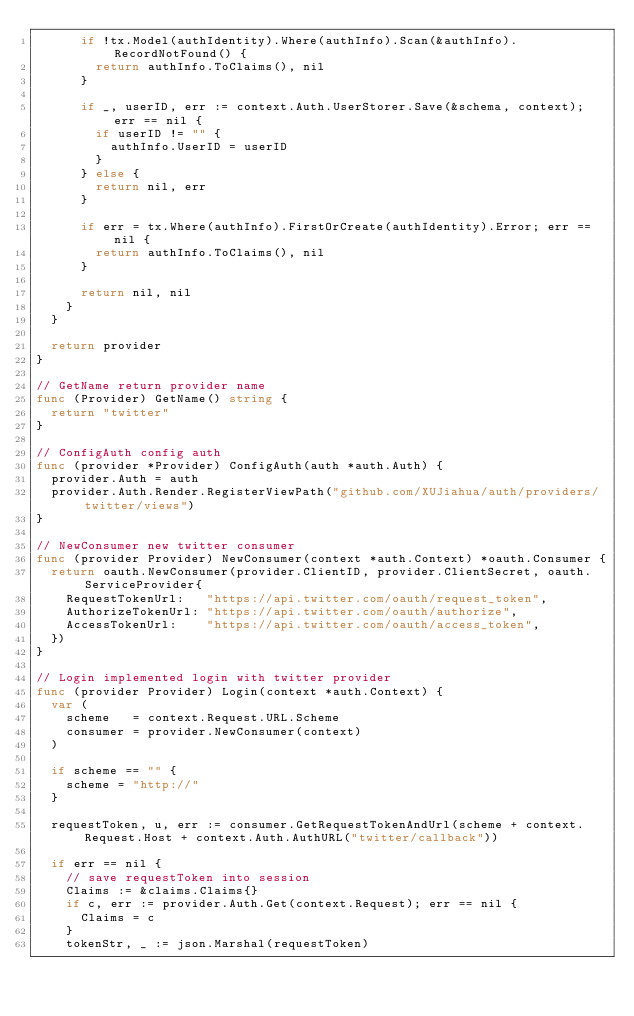<code> <loc_0><loc_0><loc_500><loc_500><_Go_>			if !tx.Model(authIdentity).Where(authInfo).Scan(&authInfo).RecordNotFound() {
				return authInfo.ToClaims(), nil
			}

			if _, userID, err := context.Auth.UserStorer.Save(&schema, context); err == nil {
				if userID != "" {
					authInfo.UserID = userID
				}
			} else {
				return nil, err
			}

			if err = tx.Where(authInfo).FirstOrCreate(authIdentity).Error; err == nil {
				return authInfo.ToClaims(), nil
			}

			return nil, nil
		}
	}

	return provider
}

// GetName return provider name
func (Provider) GetName() string {
	return "twitter"
}

// ConfigAuth config auth
func (provider *Provider) ConfigAuth(auth *auth.Auth) {
	provider.Auth = auth
	provider.Auth.Render.RegisterViewPath("github.com/XUJiahua/auth/providers/twitter/views")
}

// NewConsumer new twitter consumer
func (provider Provider) NewConsumer(context *auth.Context) *oauth.Consumer {
	return oauth.NewConsumer(provider.ClientID, provider.ClientSecret, oauth.ServiceProvider{
		RequestTokenUrl:   "https://api.twitter.com/oauth/request_token",
		AuthorizeTokenUrl: "https://api.twitter.com/oauth/authorize",
		AccessTokenUrl:    "https://api.twitter.com/oauth/access_token",
	})
}

// Login implemented login with twitter provider
func (provider Provider) Login(context *auth.Context) {
	var (
		scheme   = context.Request.URL.Scheme
		consumer = provider.NewConsumer(context)
	)

	if scheme == "" {
		scheme = "http://"
	}

	requestToken, u, err := consumer.GetRequestTokenAndUrl(scheme + context.Request.Host + context.Auth.AuthURL("twitter/callback"))

	if err == nil {
		// save requestToken into session
		Claims := &claims.Claims{}
		if c, err := provider.Auth.Get(context.Request); err == nil {
			Claims = c
		}
		tokenStr, _ := json.Marshal(requestToken)</code> 